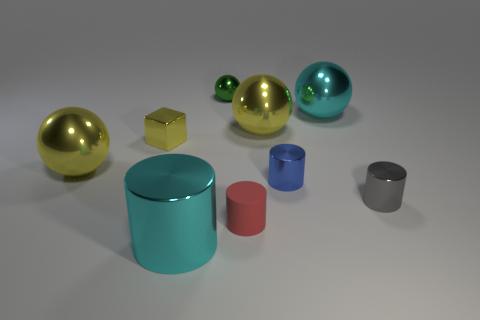Does the tiny red matte object have the same shape as the small green object?
Your response must be concise. No. There is a yellow block that is the same size as the rubber cylinder; what is it made of?
Ensure brevity in your answer.  Metal. What is the shape of the small gray thing?
Give a very brief answer. Cylinder. How many gray objects are cylinders or large shiny balls?
Ensure brevity in your answer.  1. There is a cyan object that is the same material as the cyan sphere; what size is it?
Give a very brief answer. Large. Are the cyan thing to the left of the red matte object and the big thing that is right of the blue metallic cylinder made of the same material?
Keep it short and to the point. Yes. What number of cubes are either cyan things or tiny yellow shiny things?
Ensure brevity in your answer.  1. What number of big metallic spheres are to the right of the large cyan thing on the left side of the cyan metallic object that is on the right side of the big cyan metallic cylinder?
Your answer should be very brief. 2. There is a big cyan thing that is the same shape as the small green metallic object; what material is it?
Ensure brevity in your answer.  Metal. Is there anything else that has the same material as the small red cylinder?
Offer a very short reply. No. 